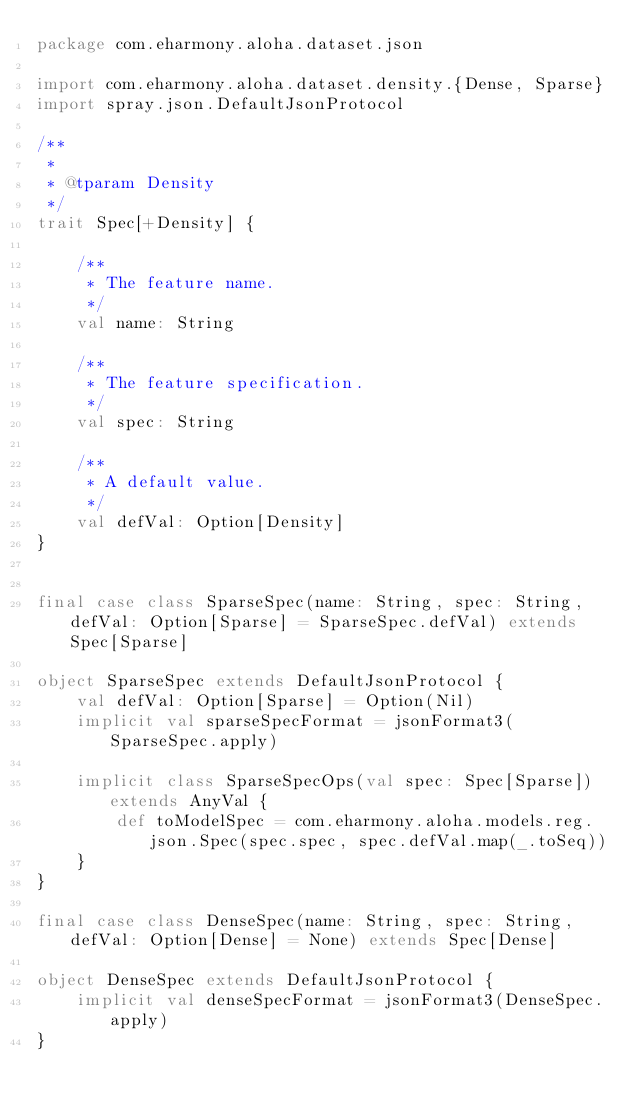Convert code to text. <code><loc_0><loc_0><loc_500><loc_500><_Scala_>package com.eharmony.aloha.dataset.json

import com.eharmony.aloha.dataset.density.{Dense, Sparse}
import spray.json.DefaultJsonProtocol

/**
 *
 * @tparam Density
 */
trait Spec[+Density] {

    /**
     * The feature name.
     */
    val name: String

    /**
     * The feature specification.
     */
    val spec: String

    /**
     * A default value.
     */
    val defVal: Option[Density]
}


final case class SparseSpec(name: String, spec: String, defVal: Option[Sparse] = SparseSpec.defVal) extends Spec[Sparse]

object SparseSpec extends DefaultJsonProtocol {
    val defVal: Option[Sparse] = Option(Nil)
    implicit val sparseSpecFormat = jsonFormat3(SparseSpec.apply)

    implicit class SparseSpecOps(val spec: Spec[Sparse]) extends AnyVal {
        def toModelSpec = com.eharmony.aloha.models.reg.json.Spec(spec.spec, spec.defVal.map(_.toSeq))
    }
}

final case class DenseSpec(name: String, spec: String, defVal: Option[Dense] = None) extends Spec[Dense]

object DenseSpec extends DefaultJsonProtocol {
    implicit val denseSpecFormat = jsonFormat3(DenseSpec.apply)
}
</code> 